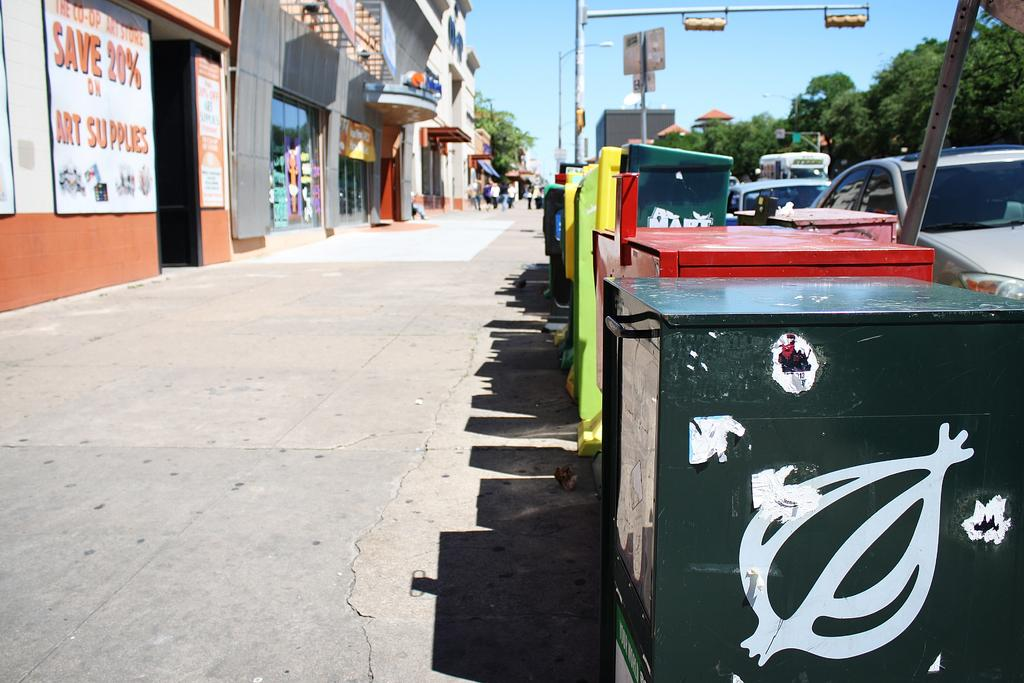<image>
Share a concise interpretation of the image provided. Newspaper dispensers line one side of a sidewalk and stores the other, one which has a Save 20% on Art Supplies sign. 